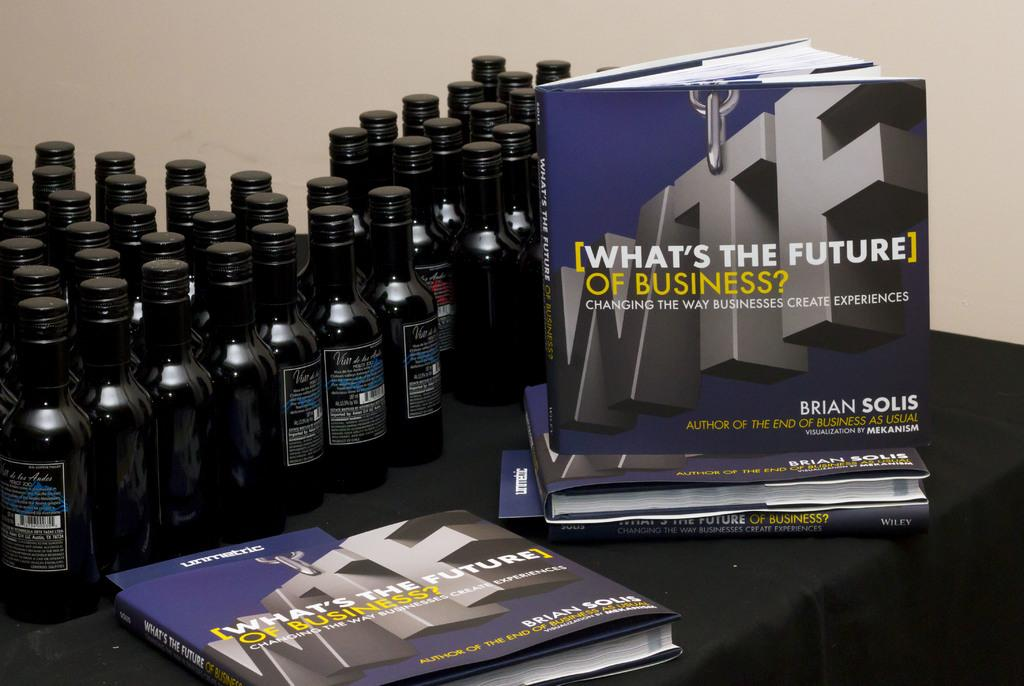<image>
Present a compact description of the photo's key features. Many bottles sit next to a book titled What 